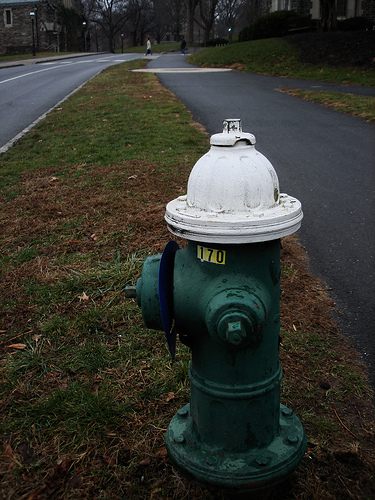Please provide the bounding box coordinate of the region this sentence describes: Large bolt on fire hydrant. The bounding box coordinates covering the large bolt on the fire hydrant are [0.63, 0.91, 0.65, 0.93]. This bolt, likely used for operational support, is positioned low on the hydrant's body. 